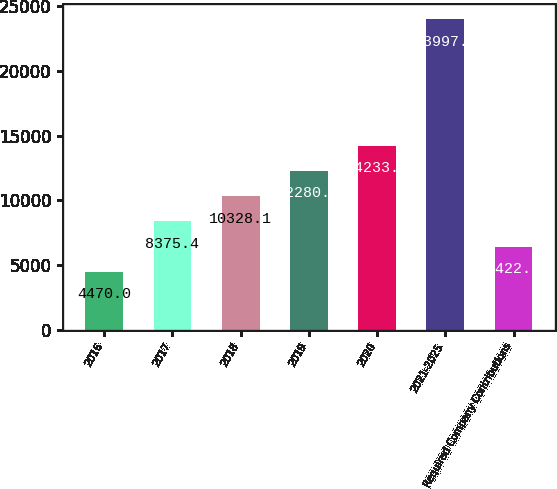<chart> <loc_0><loc_0><loc_500><loc_500><bar_chart><fcel>2016<fcel>2017<fcel>2018<fcel>2019<fcel>2020<fcel>2021-2025<fcel>Required Company Contributions<nl><fcel>4470<fcel>8375.4<fcel>10328.1<fcel>12280.8<fcel>14233.5<fcel>23997<fcel>6422.7<nl></chart> 